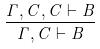<formula> <loc_0><loc_0><loc_500><loc_500>\frac { \Gamma , C , C \vdash B } { \Gamma , C \vdash B }</formula> 